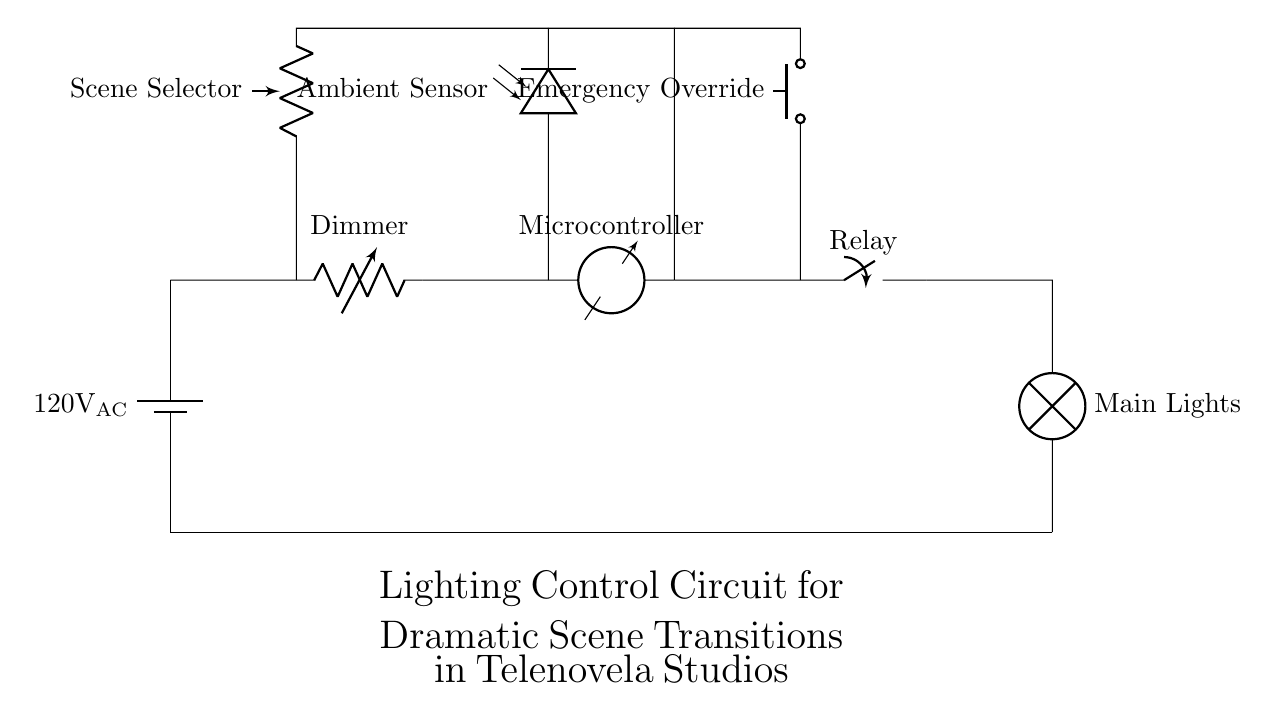What is the main power supply voltage? The main power supply voltage is indicated next to the battery symbol in the circuit diagram, which shows 120 volts AC.
Answer: 120 volts AC What component acts as the scene selector? The component labeled as Scene Selector, which is a variable resistor symbol in the circuit, serves this function.
Answer: Variable resistor How does the ambient sensor affect lighting control? The ambient sensor, represented by the photodiode, detects surrounding light levels and sends this information to the microcontroller to adjust lighting as needed. This influences how the system manages light output based on ambient conditions.
Answer: Adjusts lighting based on ambient conditions Which component is used for emergency override? The Circuit diagram indicates the Emergency Override function is achieved by the push button component, which allows users to instantly change the lighting during critical moments.
Answer: Push button What is the function of the microcontroller in this circuit? The microcontroller processes signals from the ambient sensor and scene selector to determine the appropriate lighting levels, effectively controlling the relay that powers the main lights for transitions.
Answer: Controls lighting transitions Which component operates the main lights? The circuit clearly shows that the Relay, represented as a closing switch, is responsible for controlling the power to the main lights based on the signals it receives.
Answer: Relay 